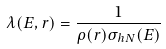Convert formula to latex. <formula><loc_0><loc_0><loc_500><loc_500>\lambda ( E , r ) = \frac { 1 } { \rho ( r ) \sigma _ { h N } ( E ) }</formula> 